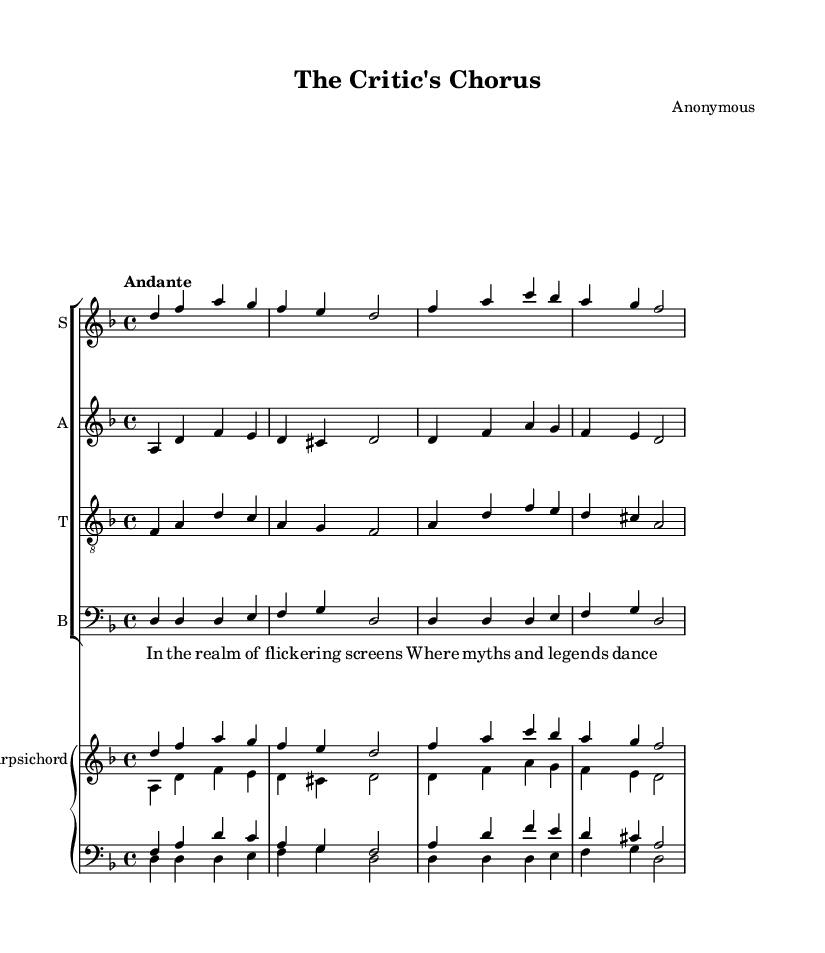What is the key signature of this music? The key signature shows two flats, indicating the music is in D minor. D minor has one flat (B♭) but typically reflects that two flats may indicate the parallel major, F major, is part of this piece.
Answer: D minor What is the time signature of this piece? The time signature appears at the beginning of the score, indicating a 4/4 time signature, meaning there are four beats in each measure.
Answer: 4/4 What is the tempo marking given in the score? The tempo marking is found below the clef, stating "Andante," which indicates a moderate walking pace. This implies a speed that is not too fast or slow.
Answer: Andante What type of ensemble performs this piece? The ensemble is indicated by the presence of multiple staves for different vocal parts (soprano, alto, tenor, bass), which identify it as a choir.
Answer: Choir How many measures is the soprano part composed of in this section? By counting the vertical lines separating the musical notations and each entry in the soprano part, it is observed that there are four measures.
Answer: Four Which instrument accompanies the choir in this score? The presence of a staff labeled "Harpsichord" and two its unique staves indicates that it is providing the accompaniment to the vocal parts.
Answer: Harpsichord What is the text theme of the lyrics presented? The lyrics depict imagery and metaphoric reflections pertaining to media and public perception. The theme focuses on flickering screens and the interplay of myths, highlighting the criticism of those elements.
Answer: Media criticism 